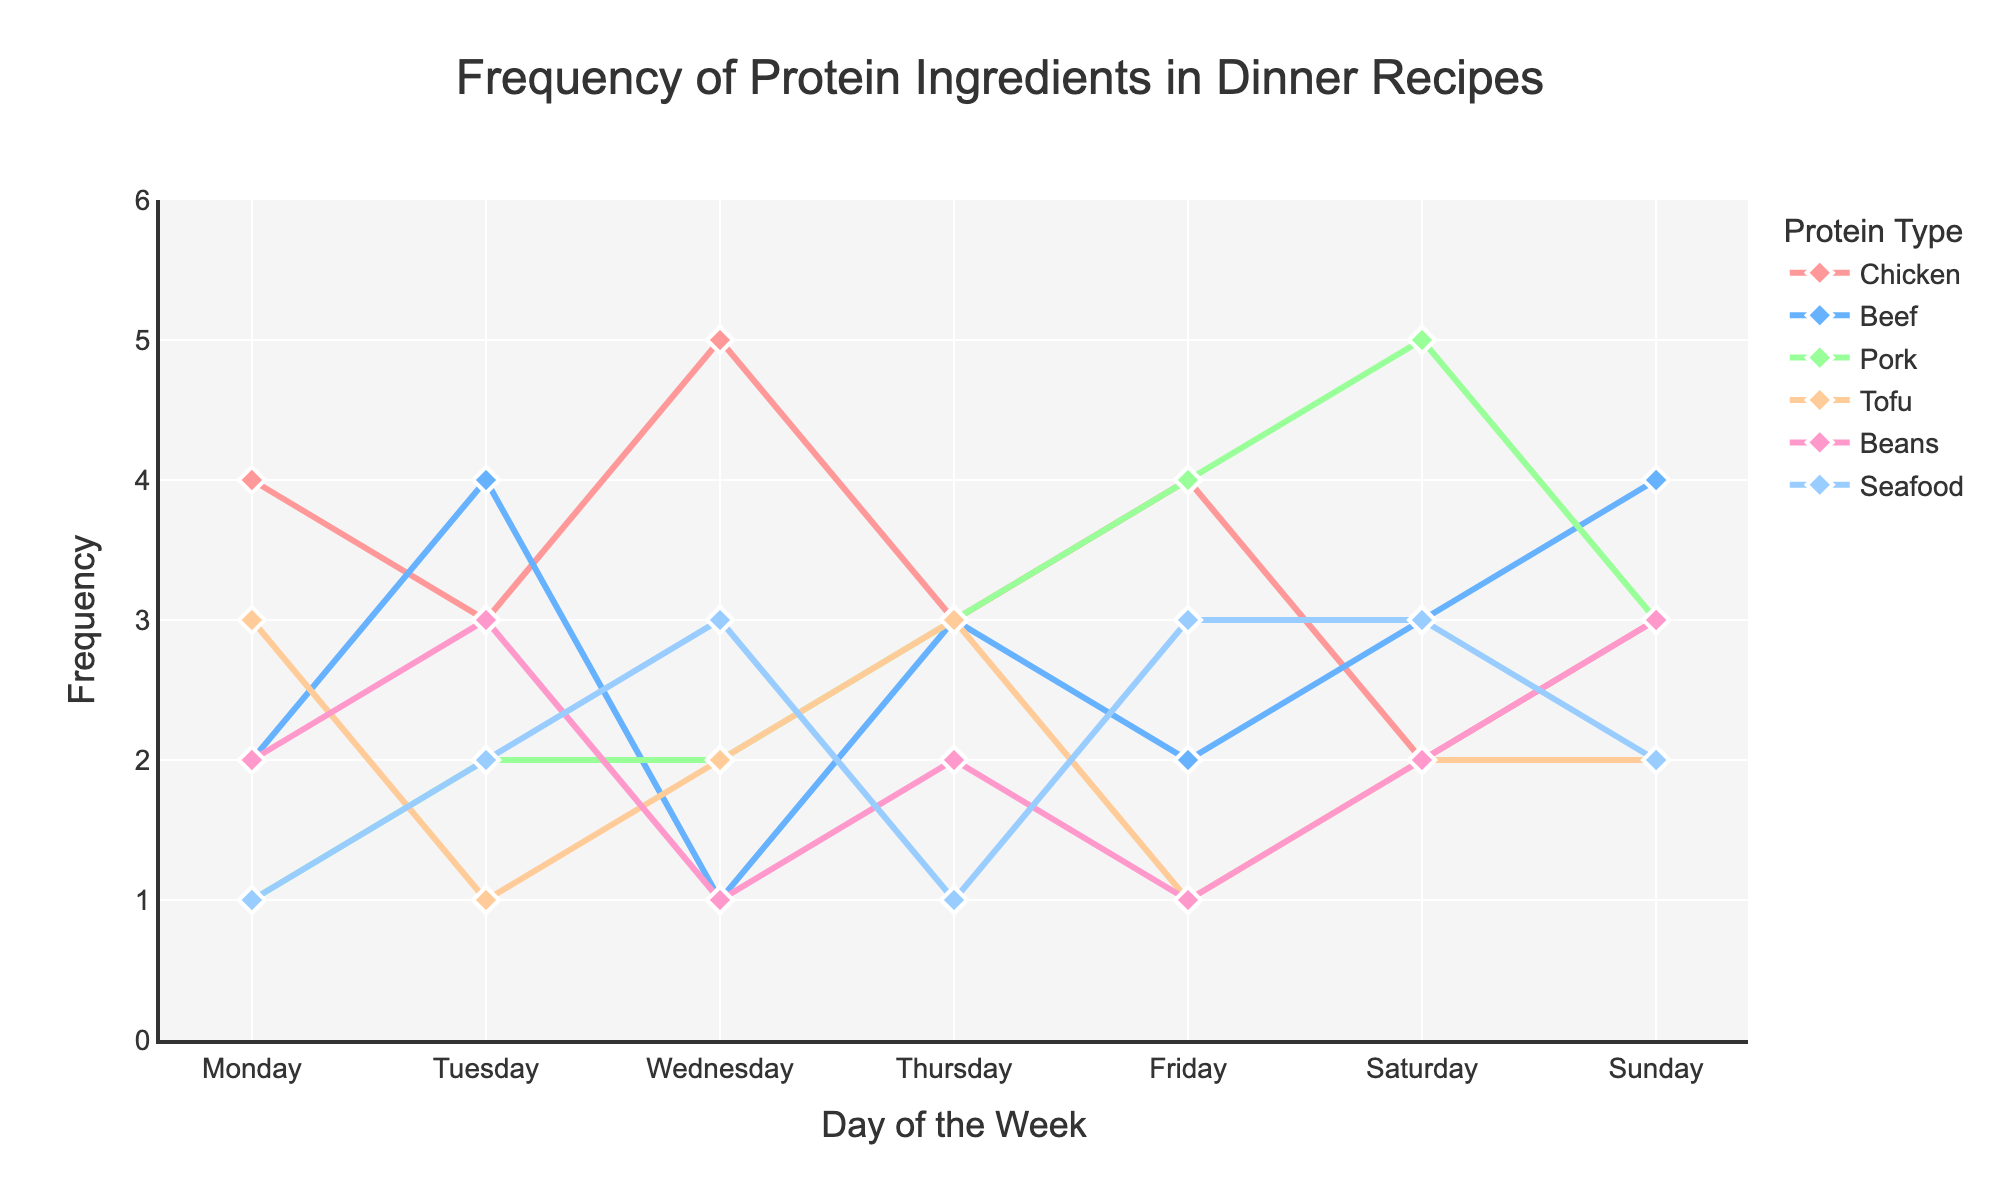How often is Chicken used in dinner recipes on Wednesday? On Wednesday, the frequency of Chicken usage is indicated by the value associated with the marker in the Chicken line plot.
Answer: 5 meals Which day has the highest frequency of Beef usage? To find the day with the highest frequency of Beef usage, check each day’s Beef frequency value in the Beef line plot and identify the maximum value.
Answer: Sunday (4 meals) What is the total frequency of Beans usage over the entire week? Sum the frequency values of Beans usage for each day: 2 (Mon) + 3 (Tue) + 1 (Wed) + 2 (Thu) + 1 (Fri) + 2 (Sat) + 3 (Sun) = 14.
Answer: 14 meals On which day is Pork used the most, and how many meals does it account for? Find the highest frequency value for Pork on the plot and identify the corresponding day. The highest value for Pork is 5, which occurs on Saturday.
Answer: Saturday, 5 meals Compare Chicken and Seafood frequencies on Friday. Which is used more and by how many meals? On Friday, find the frequencies for Chicken and Seafood. Chicken is used 4 times, while Seafood is used 3 times. The difference is 4 - 3 = 1 meal.
Answer: Chicken, 1 meal more Which protein ingredient shows the most usage variation throughout the week? To determine which protein shows the most variation, look for the protein with the widest spread in frequency values across the week. Chicken varies between 2 and 5, Beef between 1 and 4, etc. Chicken shows the highest variation (3).
Answer: Chicken What is the least used protein ingredient on Thursday? On Thursday, compare the frequency values for all protein ingredients and find the lowest one. The frequencies are: Chicken (3), Beef (3), Pork (3), Tofu (3), Beans (2), Seafood (1). Seafood is the lowest.
Answer: Seafood How does the frequency of Tofu on Monday compare to its frequency on Thursday? Check the Tofu frequency for Monday and Thursday on the plot. Monday has 3 and Thursday has 3.
Answer: Equal What is the average frequency of Pork usage over the week? Add the frequency values of Pork for each day, then divide by 7: (1+2+2+3+4+5+3) / 7 = 20 / 7 ≈ 2.86.
Answer: ~2.86 meals On which day do Seafood and Chicken have the same usage frequency? Identify the day(s) where the Seafood and Chicken lines intersect or have the same y-value. This happens on Tuesday (both at 3) and Thursday (both at 3).
Answer: Tuesday and Thursday 